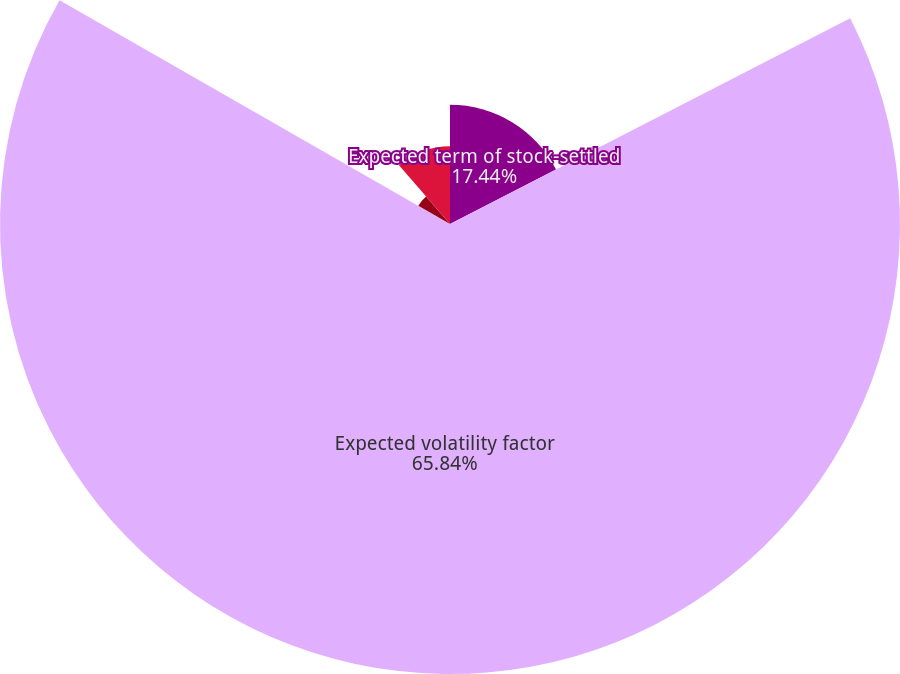<chart> <loc_0><loc_0><loc_500><loc_500><pie_chart><fcel>Expected term of stock-settled<fcel>Expected volatility factor<fcel>Expected dividend yield<fcel>Risk-free interest rate<nl><fcel>17.44%<fcel>65.84%<fcel>5.34%<fcel>11.38%<nl></chart> 